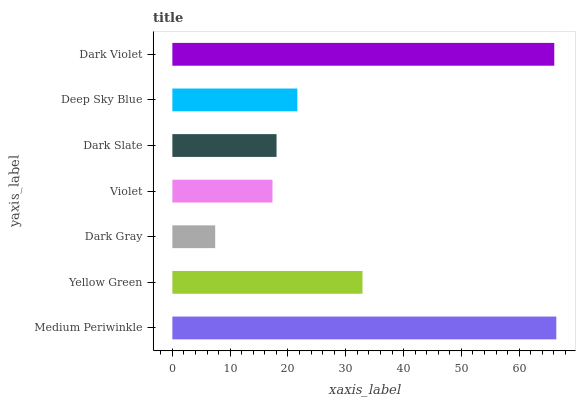Is Dark Gray the minimum?
Answer yes or no. Yes. Is Medium Periwinkle the maximum?
Answer yes or no. Yes. Is Yellow Green the minimum?
Answer yes or no. No. Is Yellow Green the maximum?
Answer yes or no. No. Is Medium Periwinkle greater than Yellow Green?
Answer yes or no. Yes. Is Yellow Green less than Medium Periwinkle?
Answer yes or no. Yes. Is Yellow Green greater than Medium Periwinkle?
Answer yes or no. No. Is Medium Periwinkle less than Yellow Green?
Answer yes or no. No. Is Deep Sky Blue the high median?
Answer yes or no. Yes. Is Deep Sky Blue the low median?
Answer yes or no. Yes. Is Dark Gray the high median?
Answer yes or no. No. Is Yellow Green the low median?
Answer yes or no. No. 